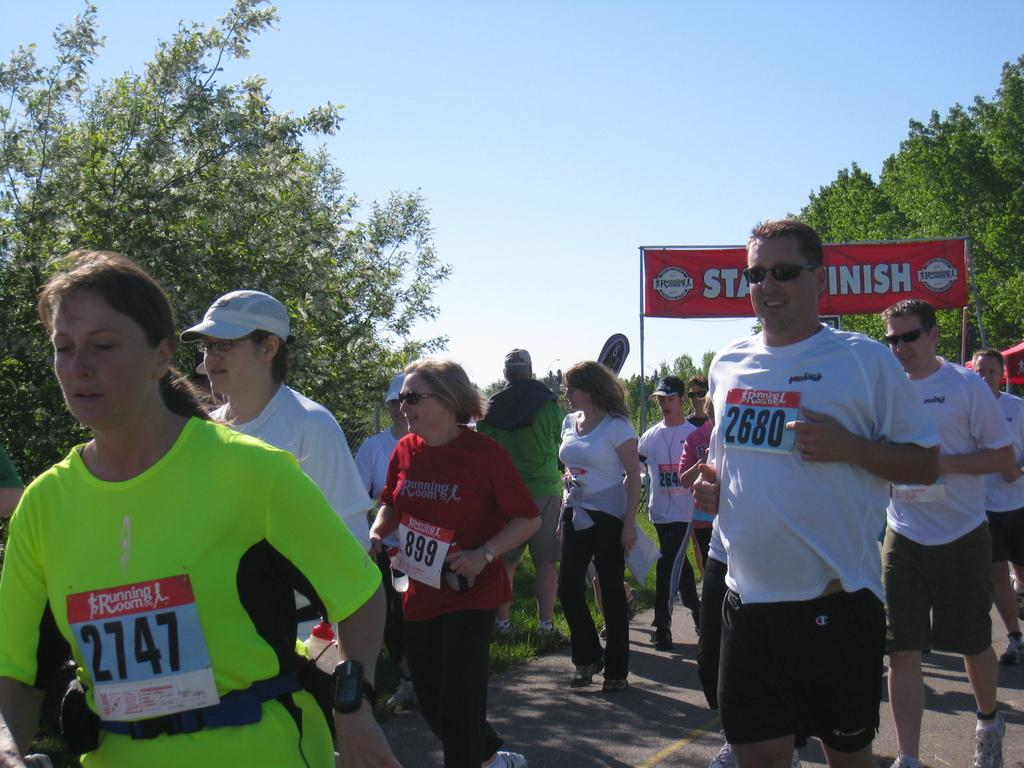What is happening in the image involving a group of people? The group of girls and boys is participating in a marathon race. What can be seen in the image that is related to the race? There is a red color banner visible in the image. What is visible in the background of the image? There are trees in the background of the image. What type of lettuce is being sorted by the group in the image? There is no lettuce or sorting activity present in the image; the group is participating in a marathon race. 